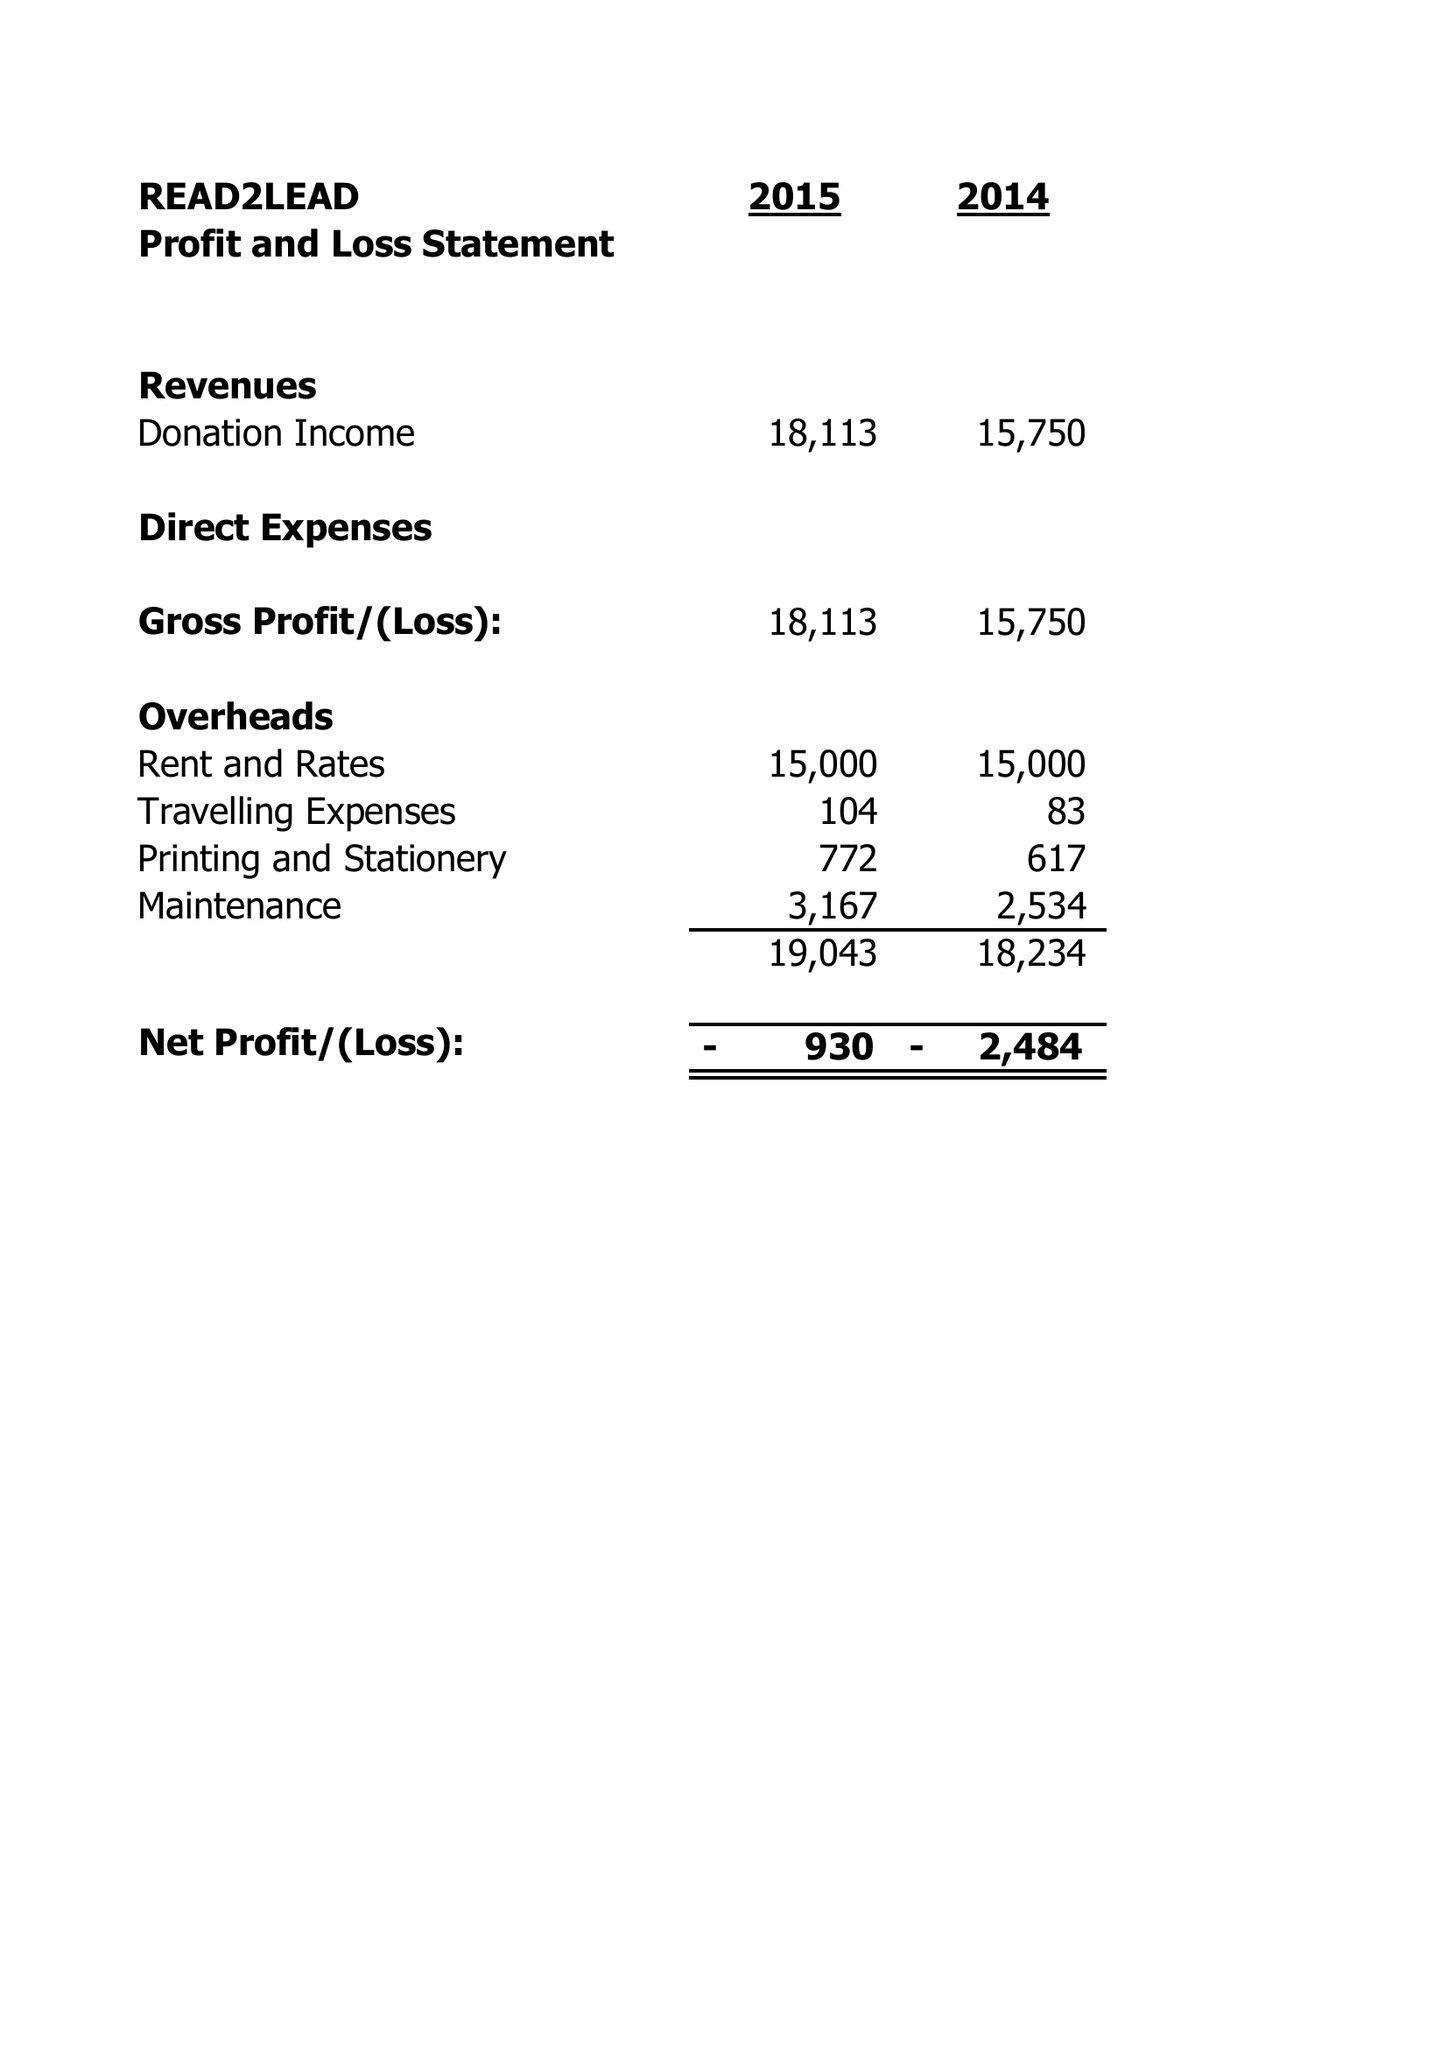What is the value for the address__street_line?
Answer the question using a single word or phrase. 43-45 WASHWOOD HEATH ROAD 